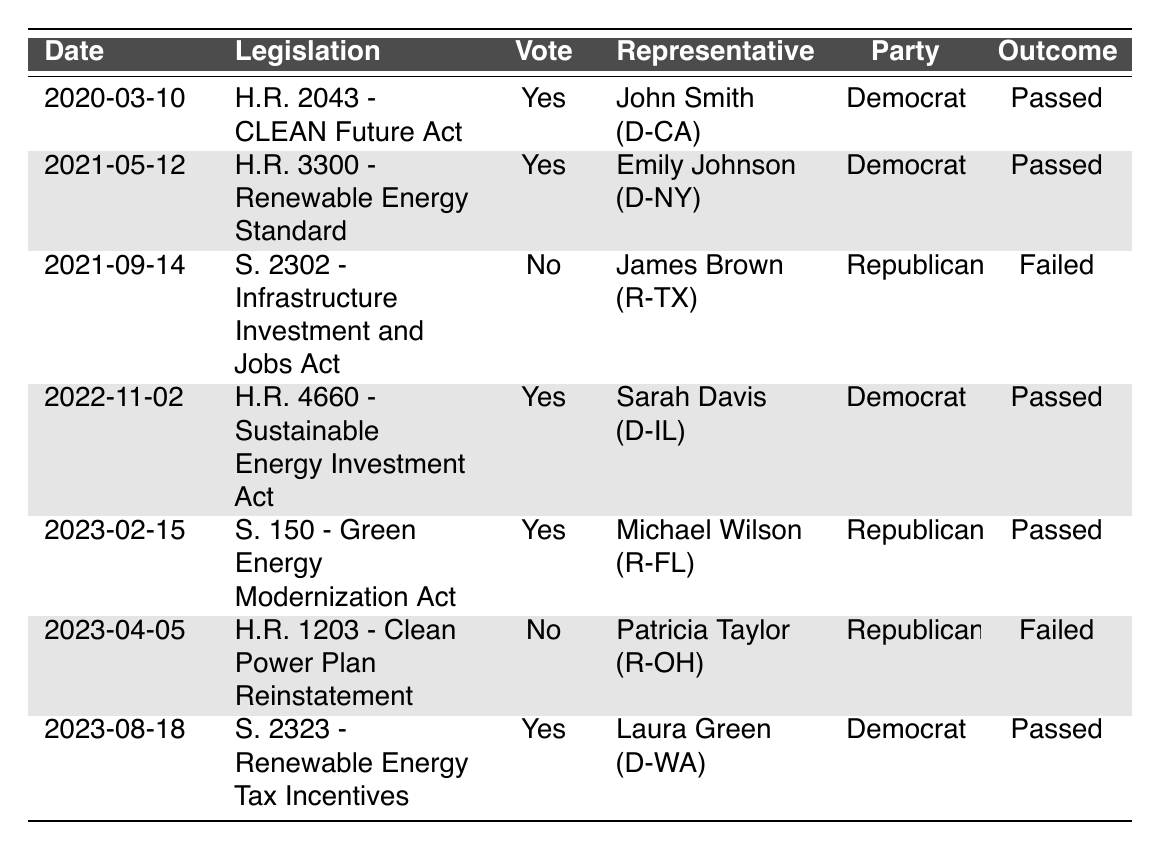What legislation was passed on March 10, 2020? The table indicates that the legislation passed on this date was "H.R. 2043 - CLEAN Future Act" with a vote of "Yes".
Answer: H.R. 2043 - CLEAN Future Act How many bills were voted on in total between 2020 and 2023? Counting the entries in the table, there are a total of 7 bills listed.
Answer: 7 What is the party affiliation of the representative who voted "No" on "S. 2302 - Infrastructure Investment and Jobs Act"? The table shows that James Brown (R-TX), who voted "No", is affiliated with the Republican Party.
Answer: Republican Which bill had a voice vote and was passed in 2021? The table specifies that "H.R. 3300 - Renewable Energy Standard", which was passed in 2021, had a voice vote.
Answer: H.R. 3300 - Renewable Energy Standard What was the outcome of the "H.R. 1203 - Clean Power Plan Reinstatement" vote? According to the table, the outcome of this legislation was "Failed", as indicated by the "No" vote from Patricia Taylor (R-OH).
Answer: Failed How many Democratic representatives voted "Yes" on renewable energy legislation? The table shows 4 Democratic representatives voted "Yes": John Smith, Emily Johnson, Sarah Davis, and Laura Green.
Answer: 4 Was there any Republican representative who voted "Yes" on renewable energy policies? The table reveals that Michael Wilson (R-FL) voted "Yes" on the "S. 150 - Green Energy Modernization Act." Thus, there is at least one Republican who voted "Yes".
Answer: Yes What percentage of the bills listed from 2020 to 2023 were passed? Out of 7 total bills, 5 were passed. Thus, percentage = (5/7) * 100 = approximately 71.43%.
Answer: Approximately 71.43% What was the most recent legislative vote recorded in the table? The last date in the table is August 18, 2023, for the bill "S. 2323 - Renewable Energy Tax Incentives".
Answer: S. 2323 - Renewable Energy Tax Incentives Which state had a representative voting "No" on renewable energy legislation? The table indicates James Brown (R-TX) from Texas voted "No" on "S. 2302 - Infrastructure Investment and Jobs Act".
Answer: Texas 